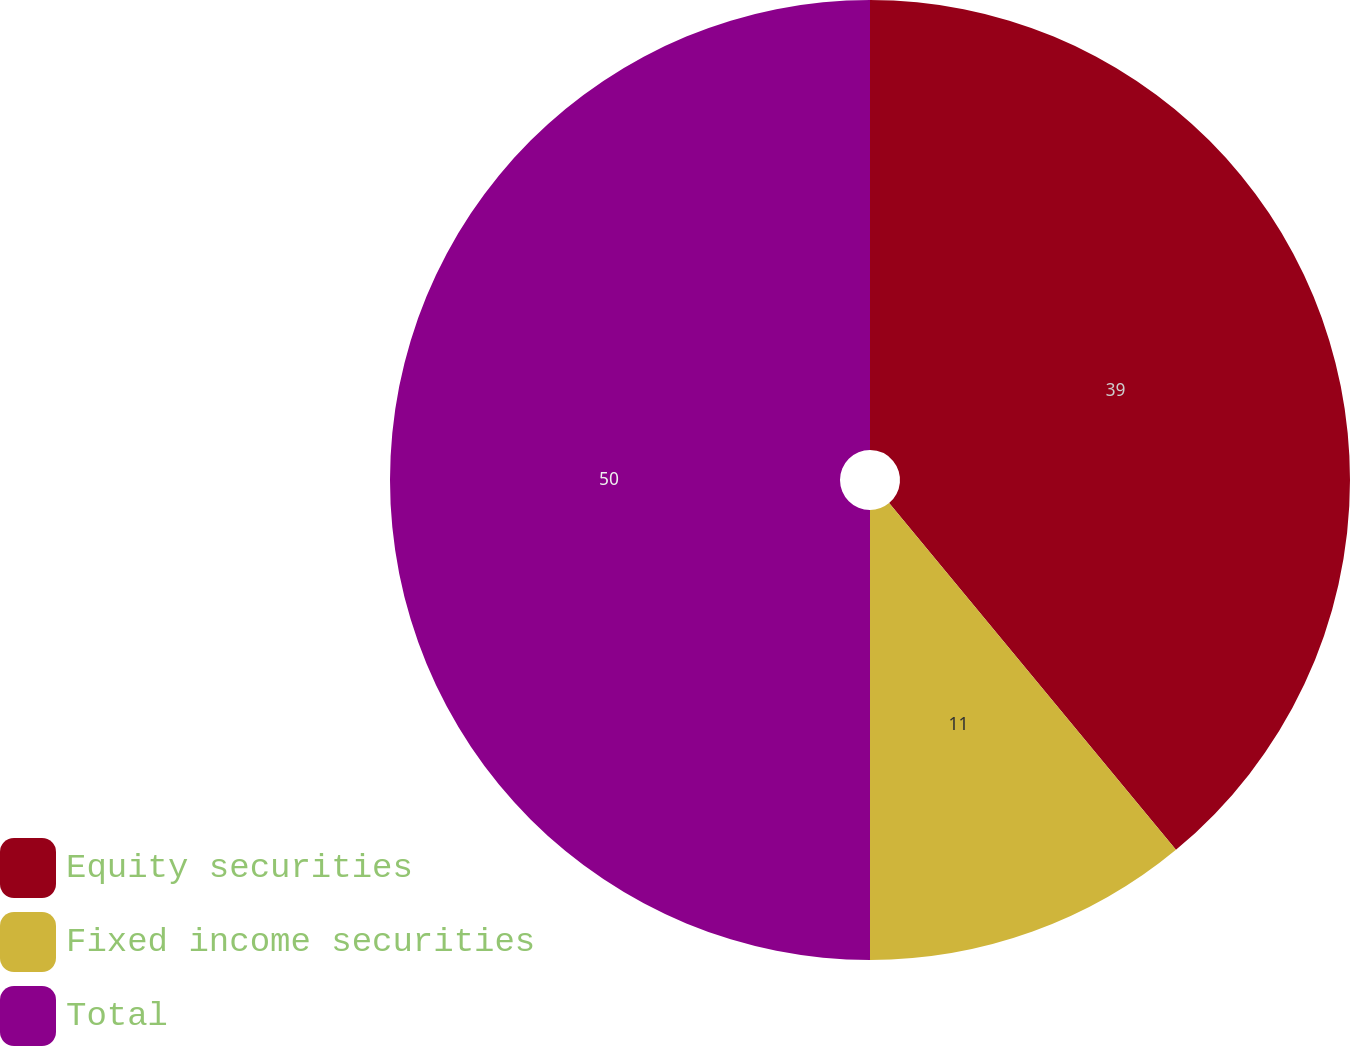Convert chart. <chart><loc_0><loc_0><loc_500><loc_500><pie_chart><fcel>Equity securities<fcel>Fixed income securities<fcel>Total<nl><fcel>39.0%<fcel>11.0%<fcel>50.0%<nl></chart> 